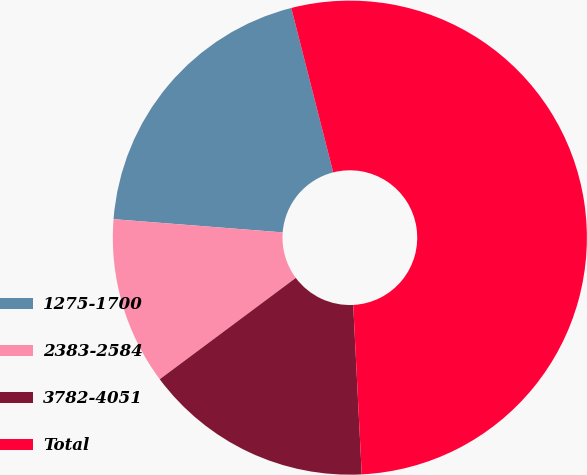Convert chart to OTSL. <chart><loc_0><loc_0><loc_500><loc_500><pie_chart><fcel>1275-1700<fcel>2383-2584<fcel>3782-4051<fcel>Total<nl><fcel>19.78%<fcel>11.43%<fcel>15.61%<fcel>53.17%<nl></chart> 